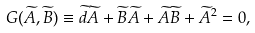<formula> <loc_0><loc_0><loc_500><loc_500>G ( \widetilde { A } , \widetilde { B } ) \equiv \widetilde { d } \widetilde { A } + \widetilde { B } \widetilde { A } + \widetilde { A } \widetilde { B } + \widetilde { A } ^ { 2 } = 0 ,</formula> 